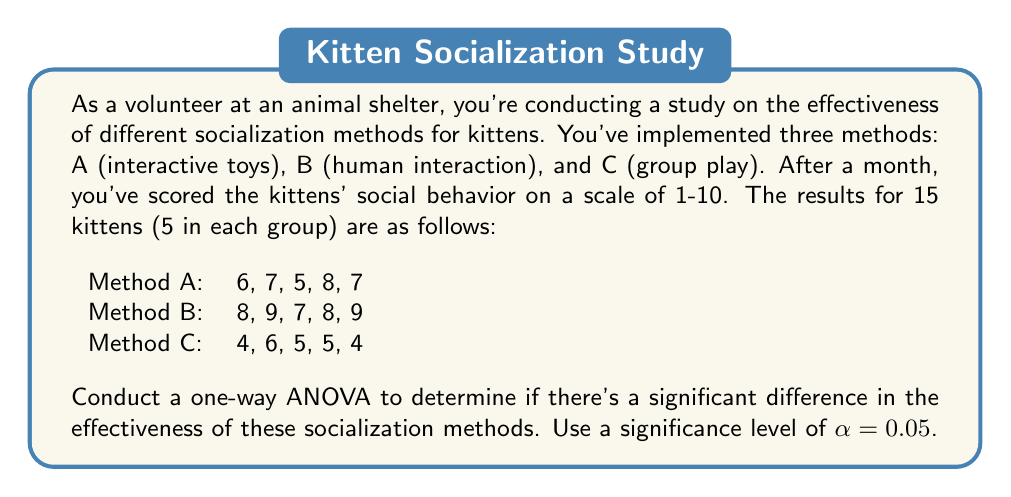Could you help me with this problem? To conduct a one-way ANOVA, we'll follow these steps:

1. Calculate the sum of squares between groups (SSB) and within groups (SSW).
2. Calculate the degrees of freedom for between groups (dfB) and within groups (dfW).
3. Calculate the mean squares for between groups (MSB) and within groups (MSW).
4. Calculate the F-statistic.
5. Compare the F-statistic to the critical F-value.

Step 1: Calculate SSB and SSW

First, we need to calculate the grand mean:
$$\bar{X} = \frac{6+7+5+8+7+8+9+7+8+9+4+6+5+5+4}{15} = 6.53$$

Now, we calculate SSB:
$$SSB = 5[(6.6-6.53)^2 + (8.2-6.53)^2 + (4.8-6.53)^2] = 36.13$$

For SSW, we calculate the sum of squared deviations within each group:
$$SSW = [(6-6.6)^2 + (7-6.6)^2 + (5-6.6)^2 + (8-6.6)^2 + (7-6.6)^2] + \\
[(8-8.2)^2 + (9-8.2)^2 + (7-8.2)^2 + (8-8.2)^2 + (9-8.2)^2] + \\
[(4-4.8)^2 + (6-4.8)^2 + (5-4.8)^2 + (5-4.8)^2 + (4-4.8)^2] = 16.4$$

Step 2: Calculate degrees of freedom

$$df_B = k - 1 = 3 - 1 = 2$$
$$df_W = N - k = 15 - 3 = 12$$

Where k is the number of groups and N is the total number of observations.

Step 3: Calculate mean squares

$$MSB = \frac{SSB}{df_B} = \frac{36.13}{2} = 18.065$$
$$MSW = \frac{SSW}{df_W} = \frac{16.4}{12} = 1.367$$

Step 4: Calculate F-statistic

$$F = \frac{MSB}{MSW} = \frac{18.065}{1.367} = 13.22$$

Step 5: Compare to critical F-value

For α = 0.05, df_B = 2, and df_W = 12, the critical F-value is approximately 3.89 (from an F-distribution table).

Since our calculated F-statistic (13.22) is greater than the critical F-value (3.89), we reject the null hypothesis.
Answer: Reject the null hypothesis. There is a significant difference in the effectiveness of the socialization methods (F(2,12) = 13.22, p < 0.05). 